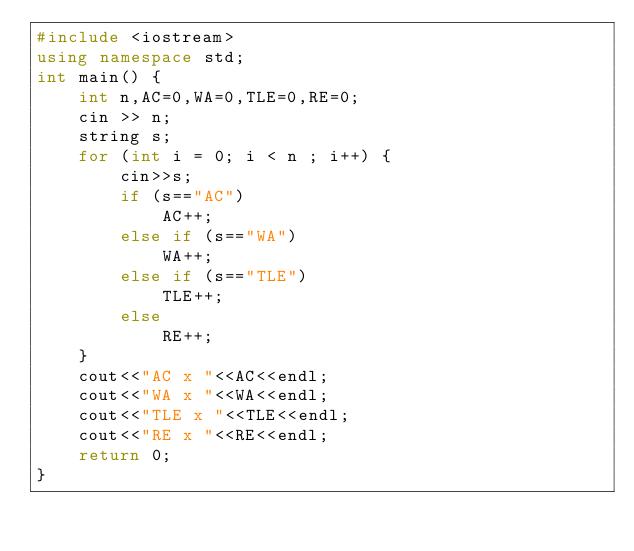Convert code to text. <code><loc_0><loc_0><loc_500><loc_500><_C++_>#include <iostream>
using namespace std;
int main() {
    int n,AC=0,WA=0,TLE=0,RE=0;
    cin >> n;
    string s;
    for (int i = 0; i < n ; i++) {
        cin>>s;
        if (s=="AC")
            AC++;
        else if (s=="WA")
            WA++;
        else if (s=="TLE")
            TLE++;
        else
            RE++;
    }
    cout<<"AC x "<<AC<<endl;
    cout<<"WA x "<<WA<<endl;
    cout<<"TLE x "<<TLE<<endl;
    cout<<"RE x "<<RE<<endl;
    return 0;
}</code> 